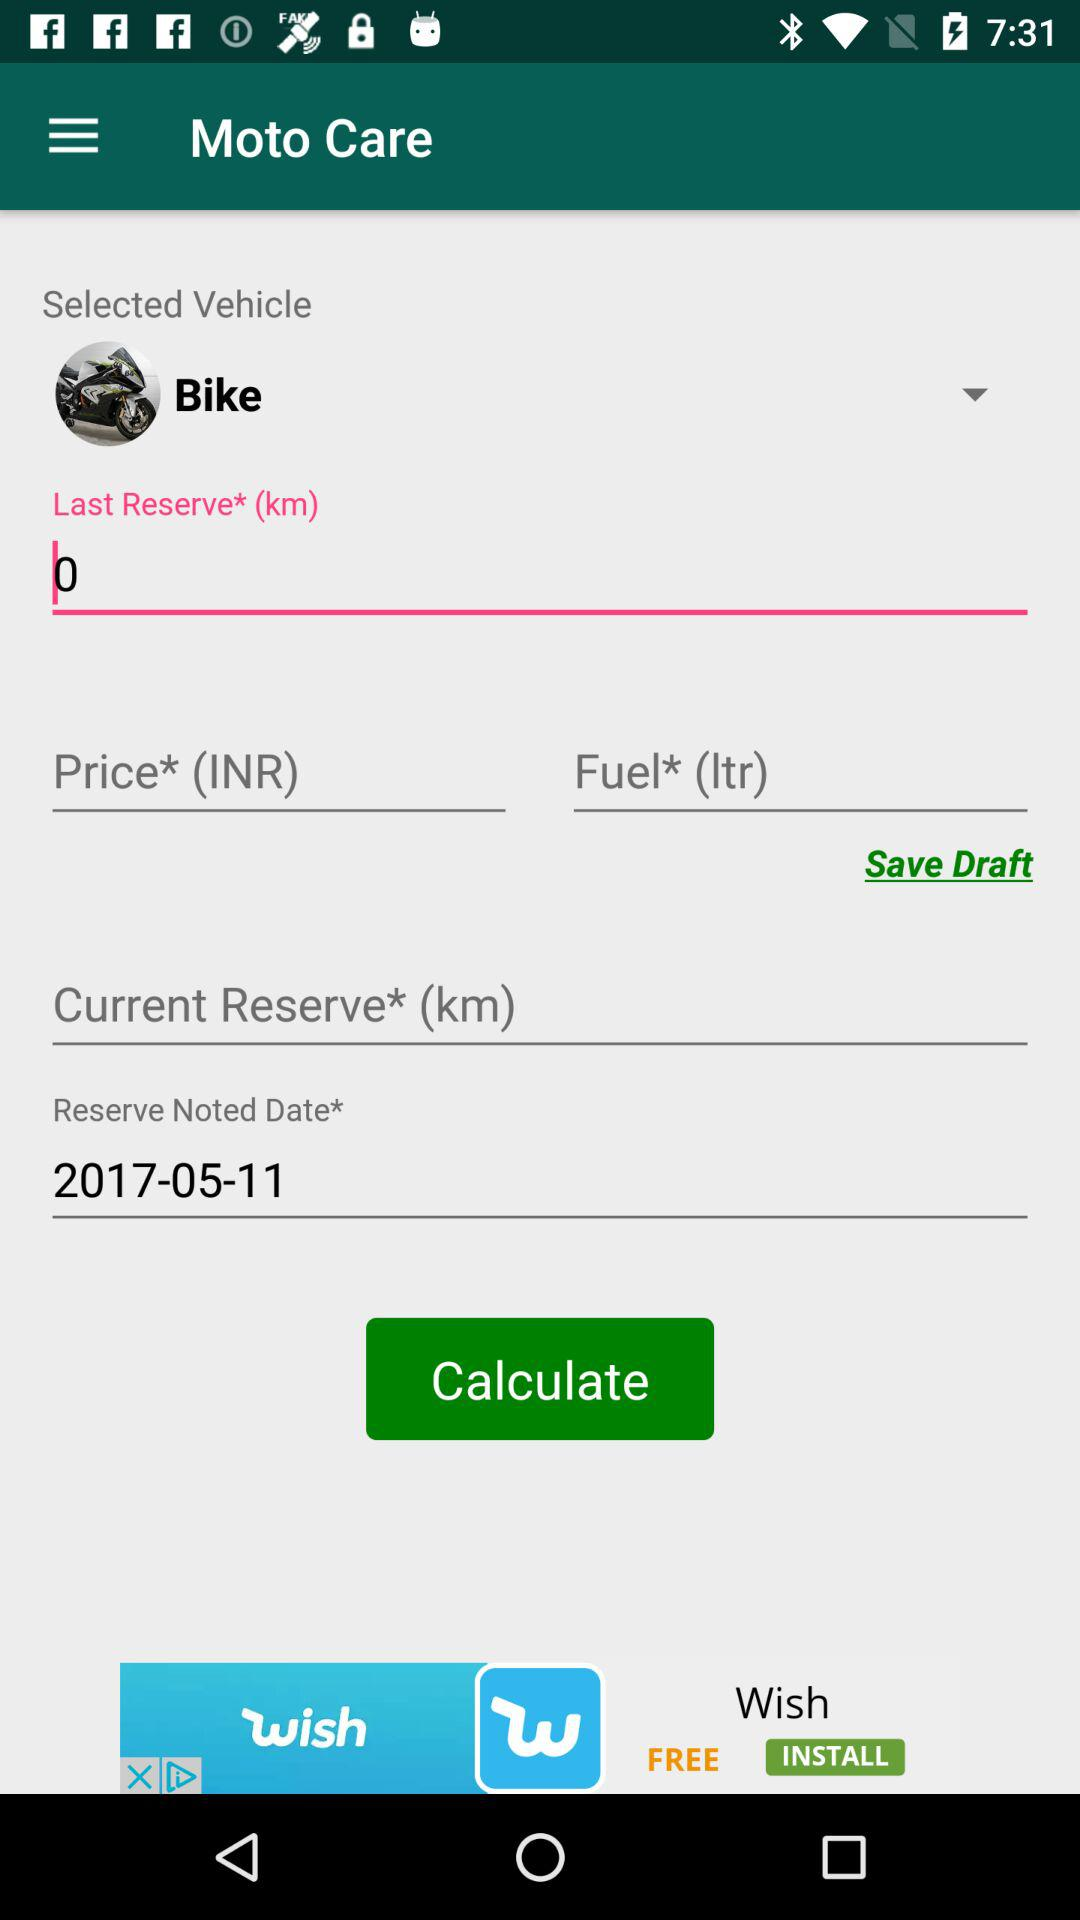What is the reserve noted date? The reserve noted date is November 5, 2017. 